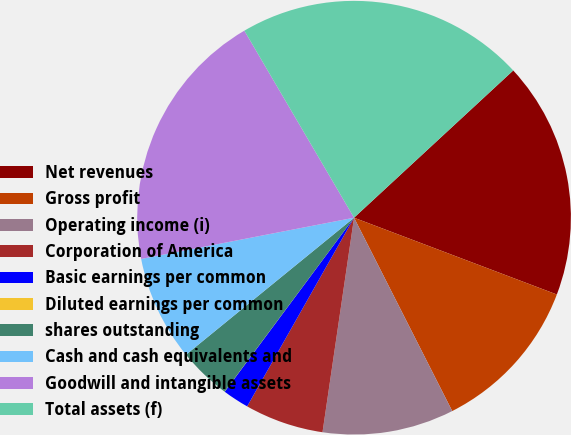Convert chart. <chart><loc_0><loc_0><loc_500><loc_500><pie_chart><fcel>Net revenues<fcel>Gross profit<fcel>Operating income (i)<fcel>Corporation of America<fcel>Basic earnings per common<fcel>Diluted earnings per common<fcel>shares outstanding<fcel>Cash and cash equivalents and<fcel>Goodwill and intangible assets<fcel>Total assets (f)<nl><fcel>17.64%<fcel>11.76%<fcel>9.8%<fcel>5.88%<fcel>1.97%<fcel>0.01%<fcel>3.93%<fcel>7.84%<fcel>19.6%<fcel>21.56%<nl></chart> 